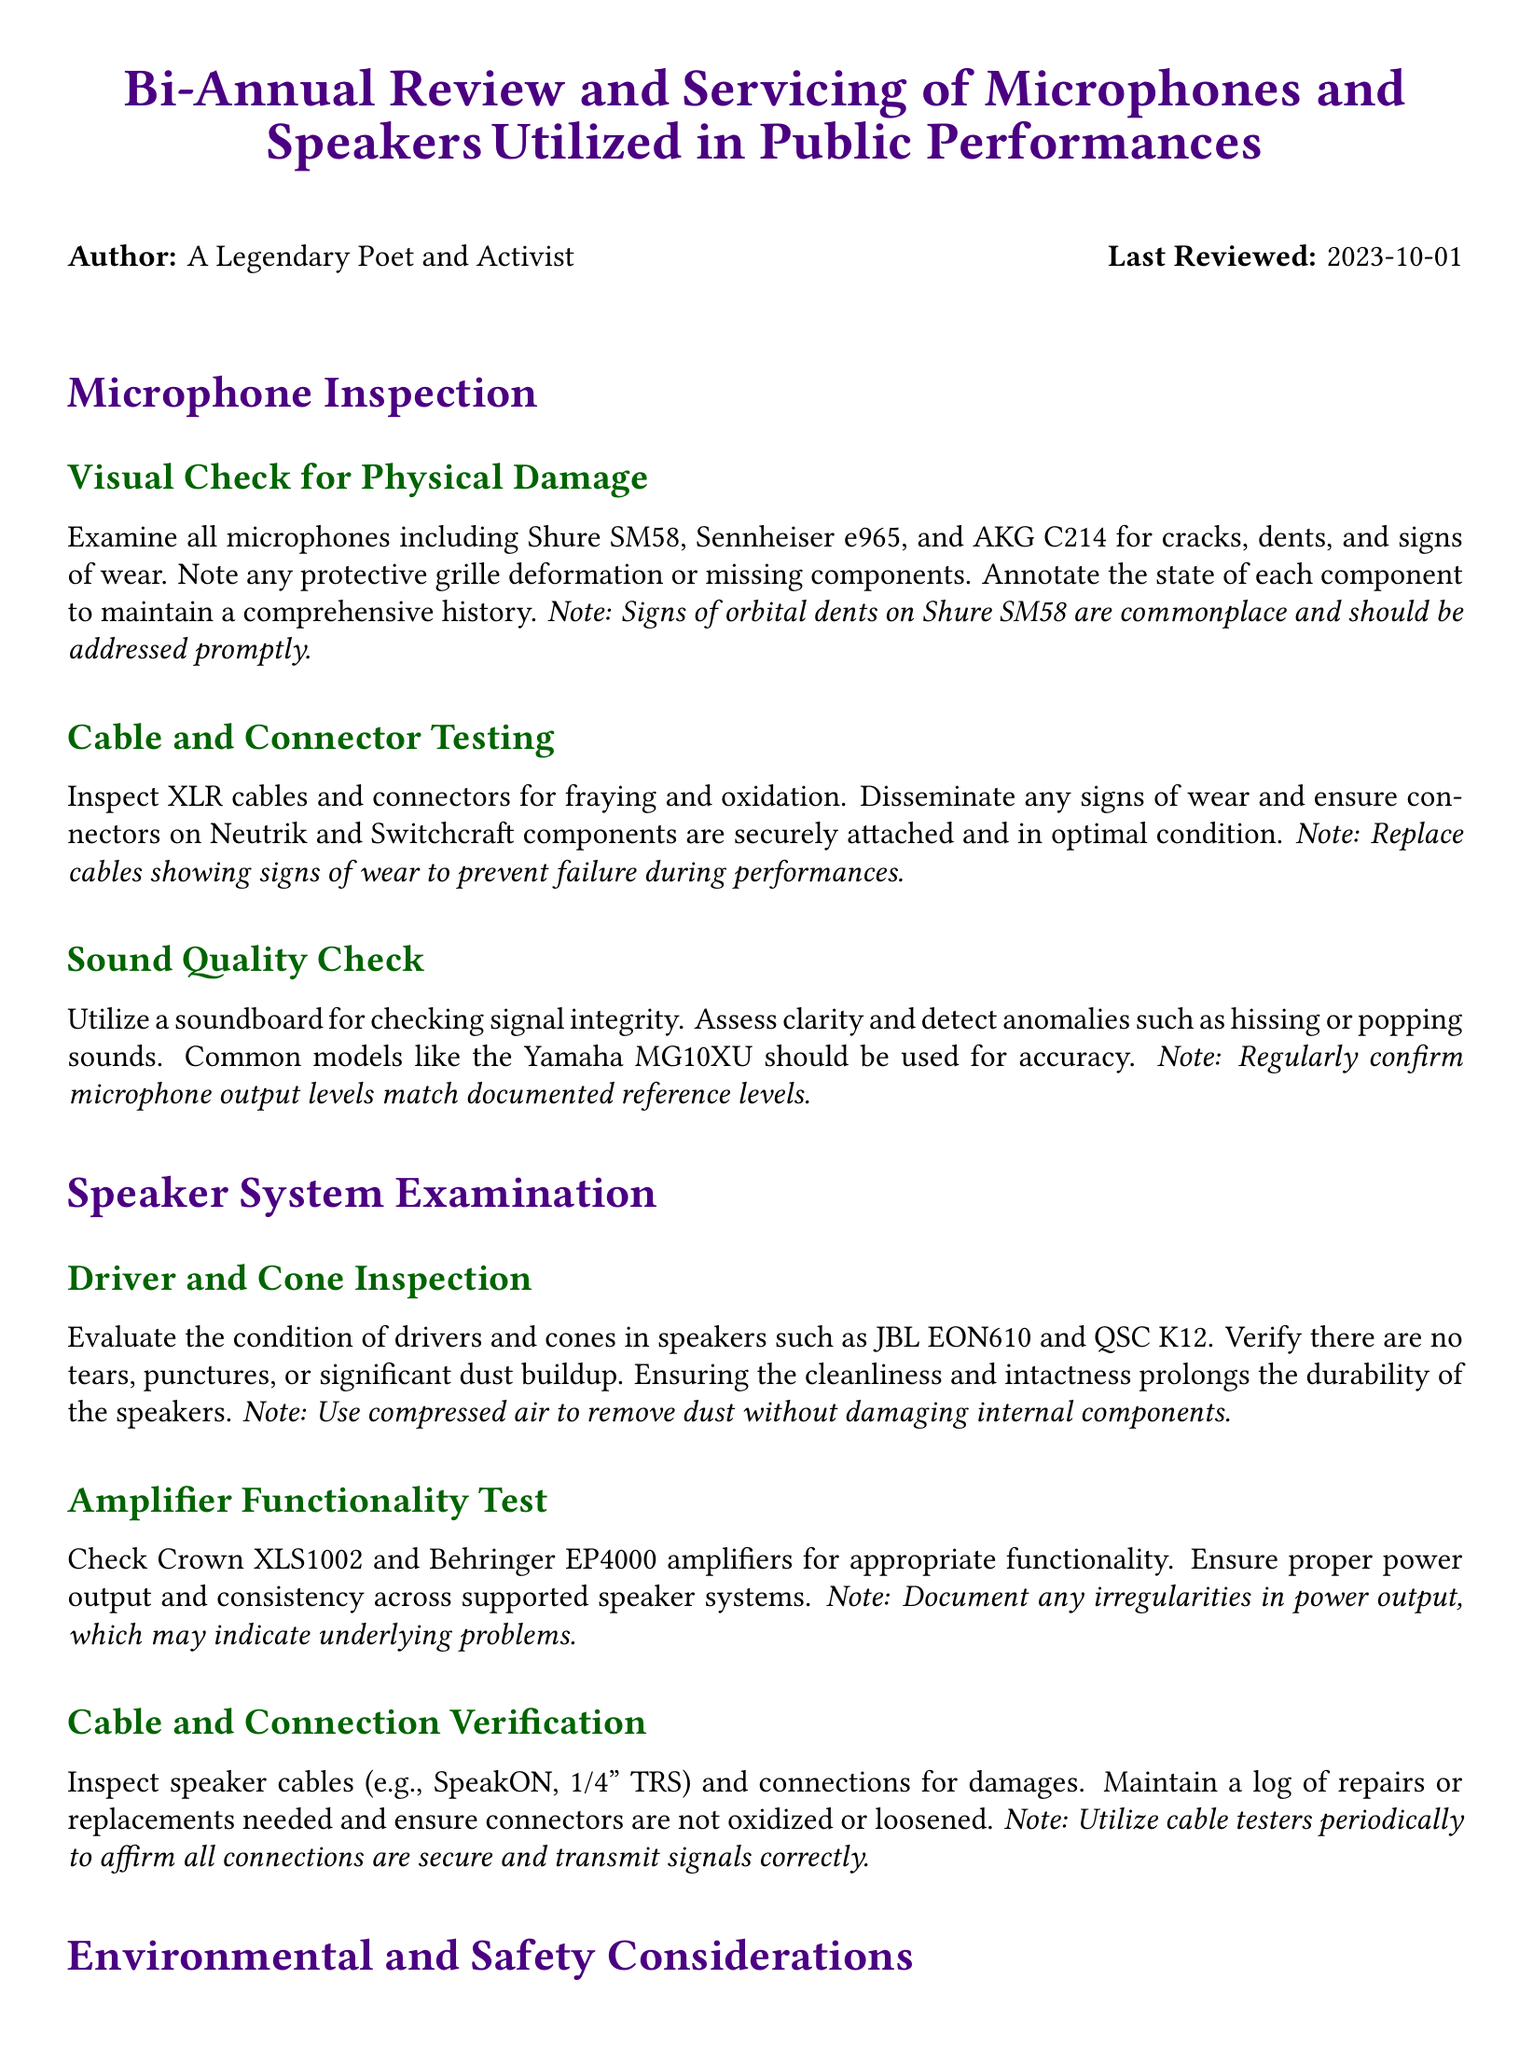What is the title of the document? The title is displayed prominently at the top of the document, stating the focus of the review and servicing.
Answer: Bi-Annual Review and Servicing of Microphones and Speakers Utilized in Public Performances Who is the author of the document? The author is specified in the introductory section of the document, identifying the individual responsible for the review.
Answer: A Legendary Poet and Activist What date was the document last reviewed? The last reviewed date is included in the author section, indicating when the document was most recently updated.
Answer: 2023-10-01 Which microphone is noted for common orbital dents? A specific note regarding a potential issue with one of the microphones is included in the inspection section.
Answer: Shure SM58 What should be used to remove dust from speakers? A guideline included in the document specifies the method for cleaning the speakers without causing damage.
Answer: Compressed air What is one of the amplifiers mentioned in the document? The document lists specific amplifier models during the examination of the speaker system, referencing their functionality.
Answer: Crown XLS1002 What should be checked to ensure electrical components' compliance? A safety precaution is indicated in the document, implying a review to ensure adherence to standards.
Answer: Current safety standards How often should cable testers be utilized? The document implies a regularity around the use of tools to verify connections, though exact frequency isn't specified.
Answer: Periodically 